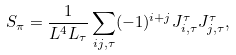Convert formula to latex. <formula><loc_0><loc_0><loc_500><loc_500>S _ { \pi } = \frac { 1 } { L ^ { 4 } L _ { \tau } } \sum _ { i j , \tau } ( - 1 ) ^ { i + j } J ^ { \tau } _ { i , \tau } J ^ { \tau } _ { j , \tau } ,</formula> 